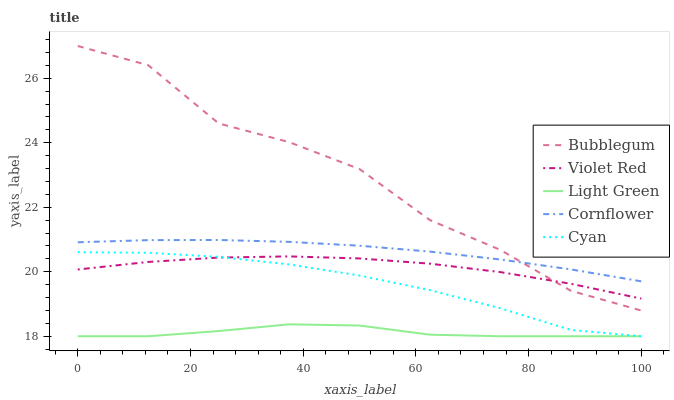Does Light Green have the minimum area under the curve?
Answer yes or no. Yes. Does Bubblegum have the maximum area under the curve?
Answer yes or no. Yes. Does Violet Red have the minimum area under the curve?
Answer yes or no. No. Does Violet Red have the maximum area under the curve?
Answer yes or no. No. Is Cornflower the smoothest?
Answer yes or no. Yes. Is Bubblegum the roughest?
Answer yes or no. Yes. Is Violet Red the smoothest?
Answer yes or no. No. Is Violet Red the roughest?
Answer yes or no. No. Does Violet Red have the lowest value?
Answer yes or no. No. Does Bubblegum have the highest value?
Answer yes or no. Yes. Does Violet Red have the highest value?
Answer yes or no. No. Is Violet Red less than Cornflower?
Answer yes or no. Yes. Is Bubblegum greater than Light Green?
Answer yes or no. Yes. Does Light Green intersect Cyan?
Answer yes or no. Yes. Is Light Green less than Cyan?
Answer yes or no. No. Is Light Green greater than Cyan?
Answer yes or no. No. Does Violet Red intersect Cornflower?
Answer yes or no. No. 